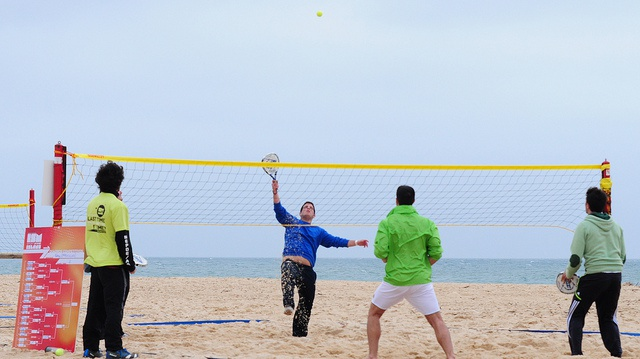Describe the objects in this image and their specific colors. I can see people in lavender, black, and khaki tones, people in lavender, lightgreen, green, darkgray, and brown tones, people in lavender, black, darkgray, and gray tones, people in lavender, black, navy, darkblue, and gray tones, and tennis racket in lavender, darkgray, and gray tones in this image. 